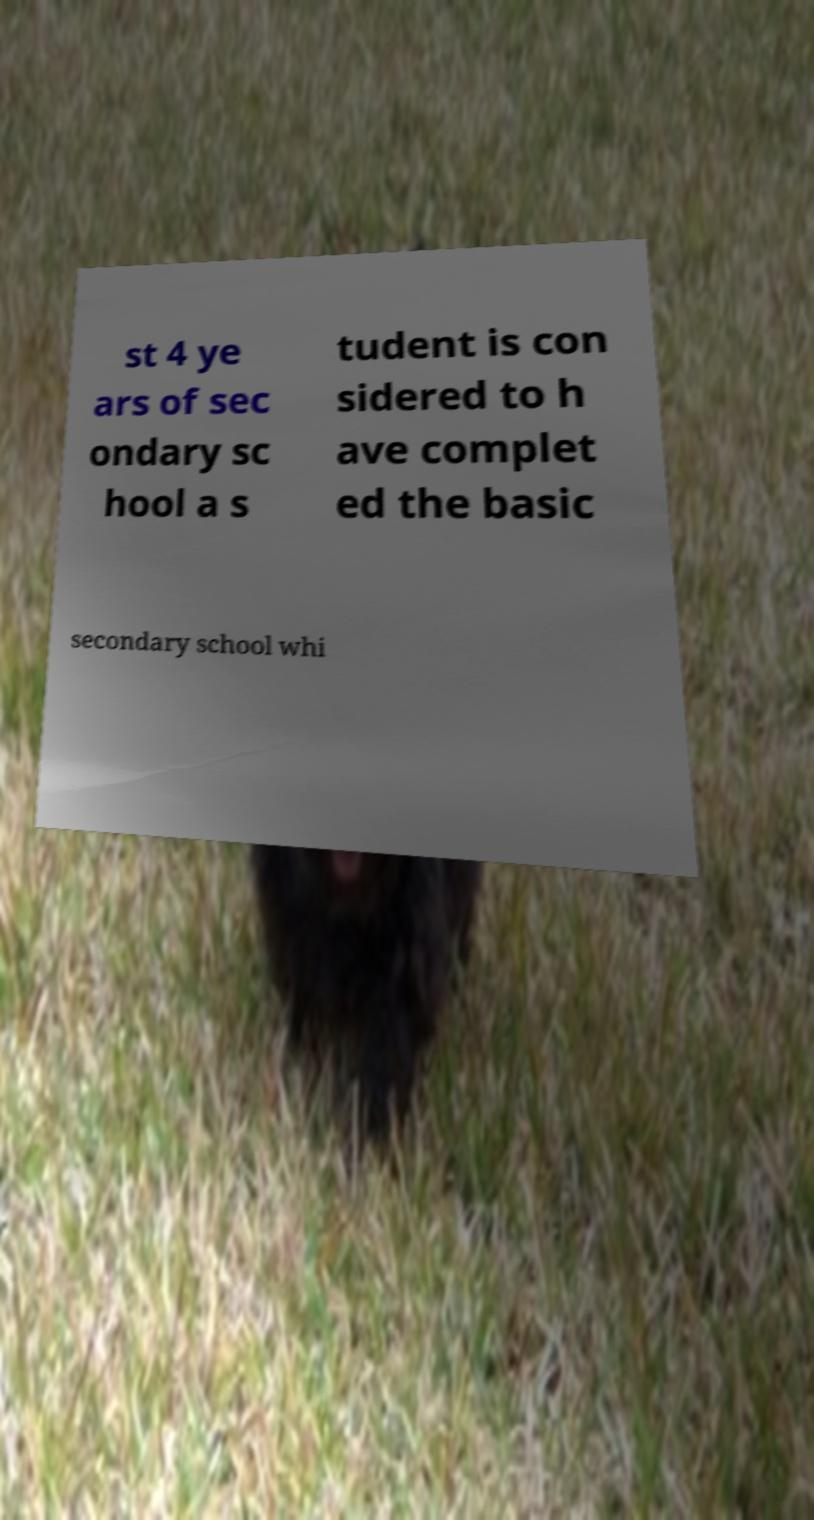Can you accurately transcribe the text from the provided image for me? st 4 ye ars of sec ondary sc hool a s tudent is con sidered to h ave complet ed the basic secondary school whi 